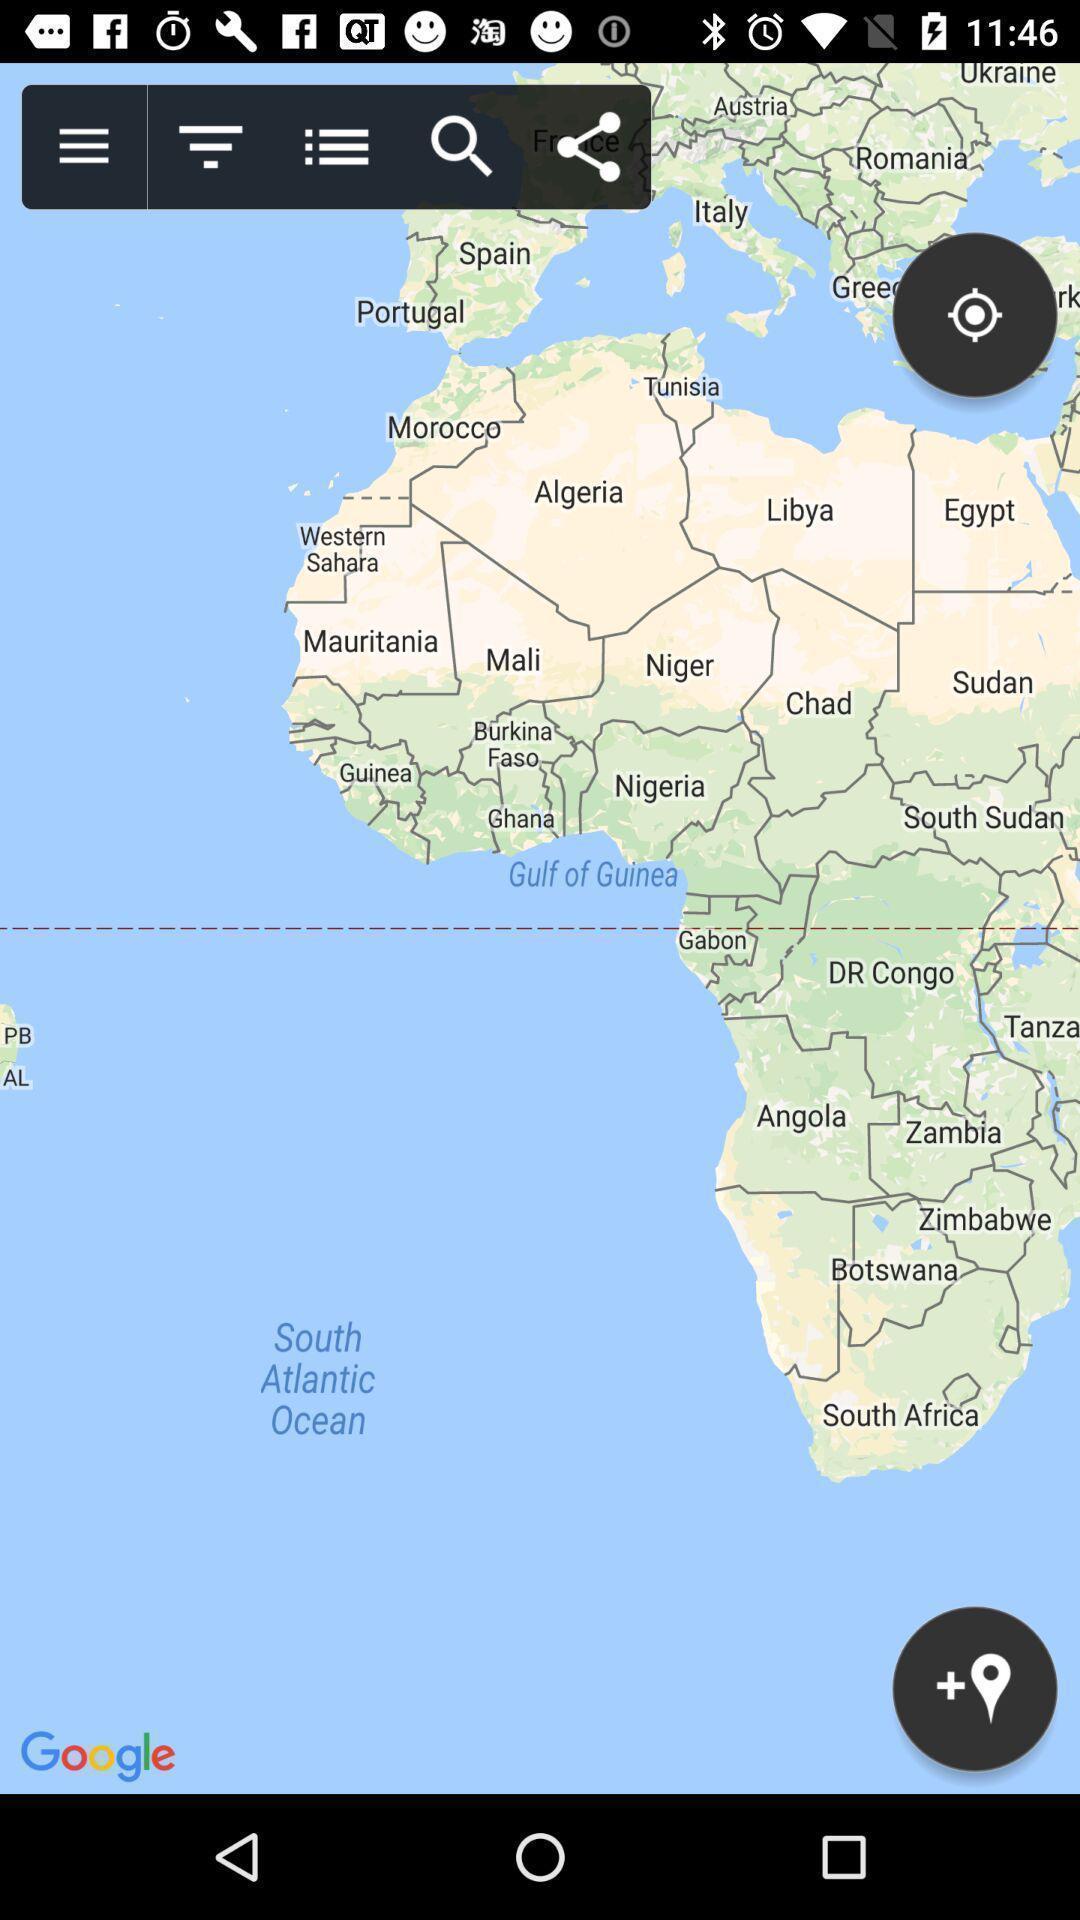Provide a detailed account of this screenshot. Screen shows a page of map. 